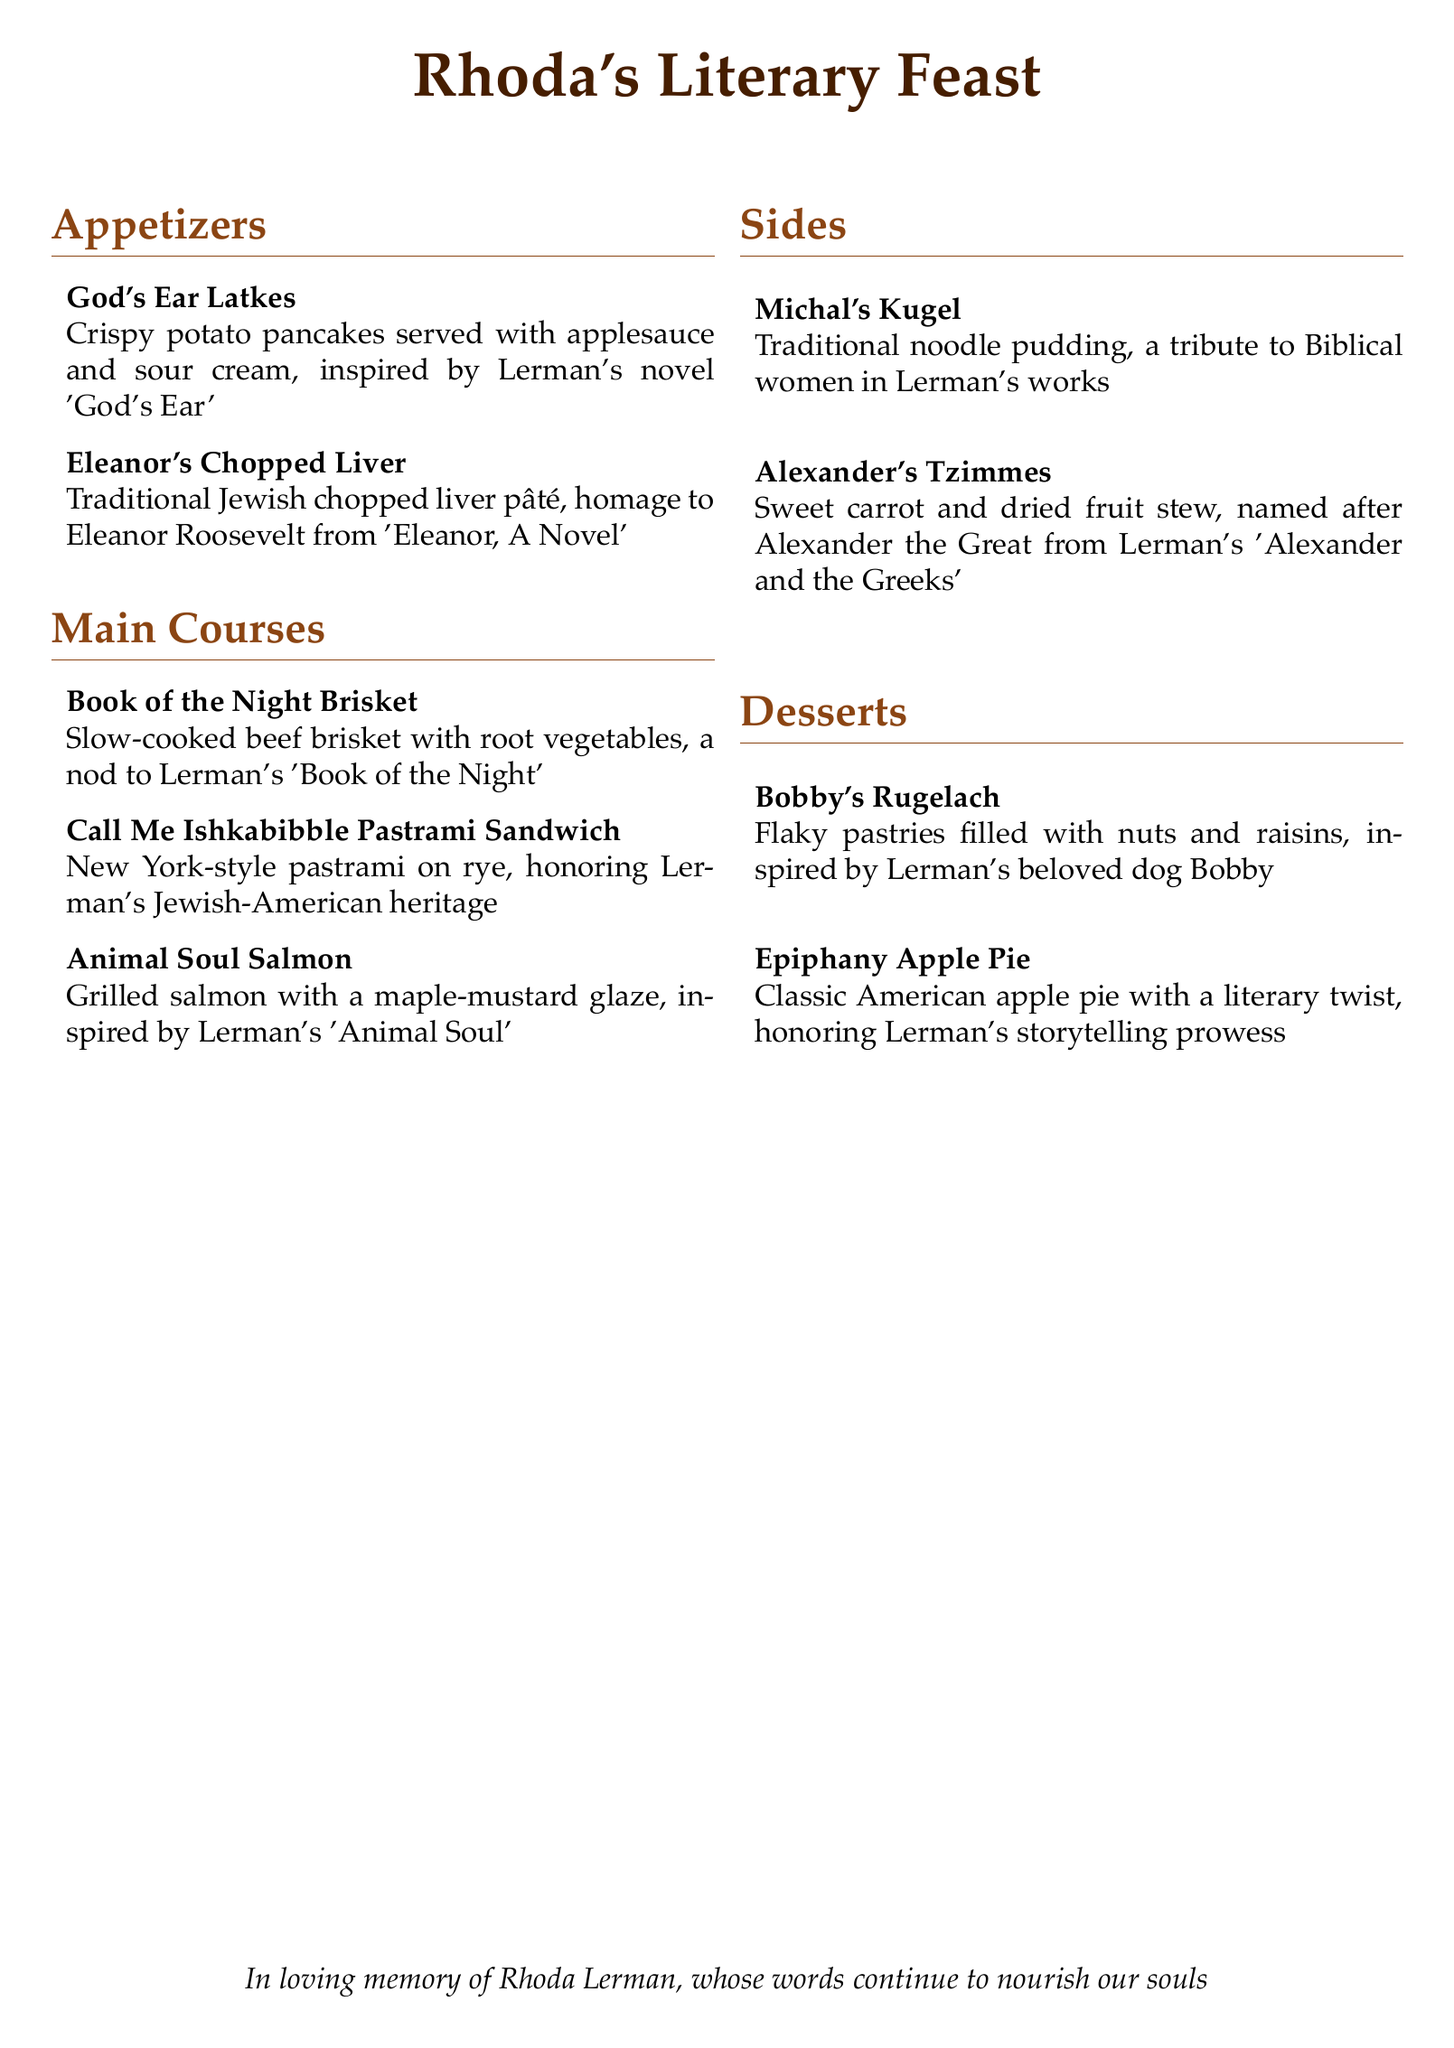What is the name of the first appetizer? The first appetizer listed is 'God's Ear Latkes'.
Answer: God's Ear Latkes Which dessert is inspired by Rhoda Lerman's dog? The dessert named 'Bobby's Rugelach' is inspired by her dog.
Answer: Bobby's Rugelach What main course honors Lerman's Jewish-American heritage? The main course called 'Call Me Ishkabibble Pastrami Sandwich' honors her heritage.
Answer: Call Me Ishkabibble Pastrami Sandwich How many sides are offered on the menu? There are two sides offered in the menu.
Answer: 2 What is the title of the dessert that honors Lerman's storytelling? The dessert that honors her storytelling is 'Epiphany Apple Pie'.
Answer: Epiphany Apple Pie Which appetizer is an homage to Eleanor Roosevelt? The appetizer named 'Eleanor's Chopped Liver' is an homage to Eleanor Roosevelt.
Answer: Eleanor's Chopped Liver What is the main ingredient in 'Michal's Kugel'? The main ingredient in 'Michal's Kugel' is noodles.
Answer: Noodles In which section can you find 'Animal Soul Salmon'? 'Animal Soul Salmon' is located in the main courses section.
Answer: Main Courses 